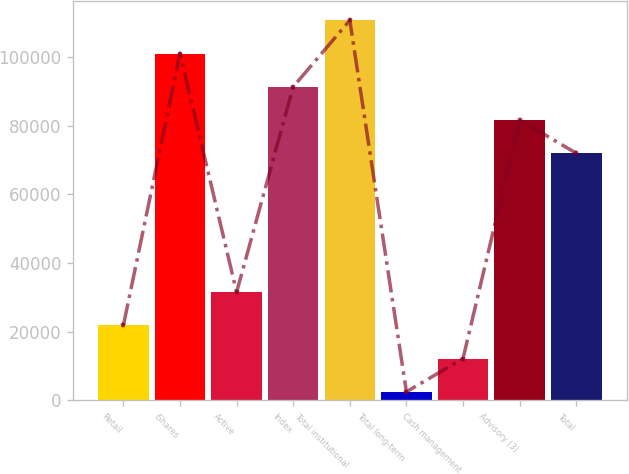Convert chart. <chart><loc_0><loc_0><loc_500><loc_500><bar_chart><fcel>Retail<fcel>iShares<fcel>Active<fcel>Index<fcel>Total institutional<fcel>Total long-term<fcel>Cash management<fcel>Advisory (3)<fcel>Total<nl><fcel>21809.6<fcel>100974<fcel>31481.9<fcel>91301.6<fcel>110646<fcel>2465<fcel>12137.3<fcel>81629.3<fcel>71957<nl></chart> 